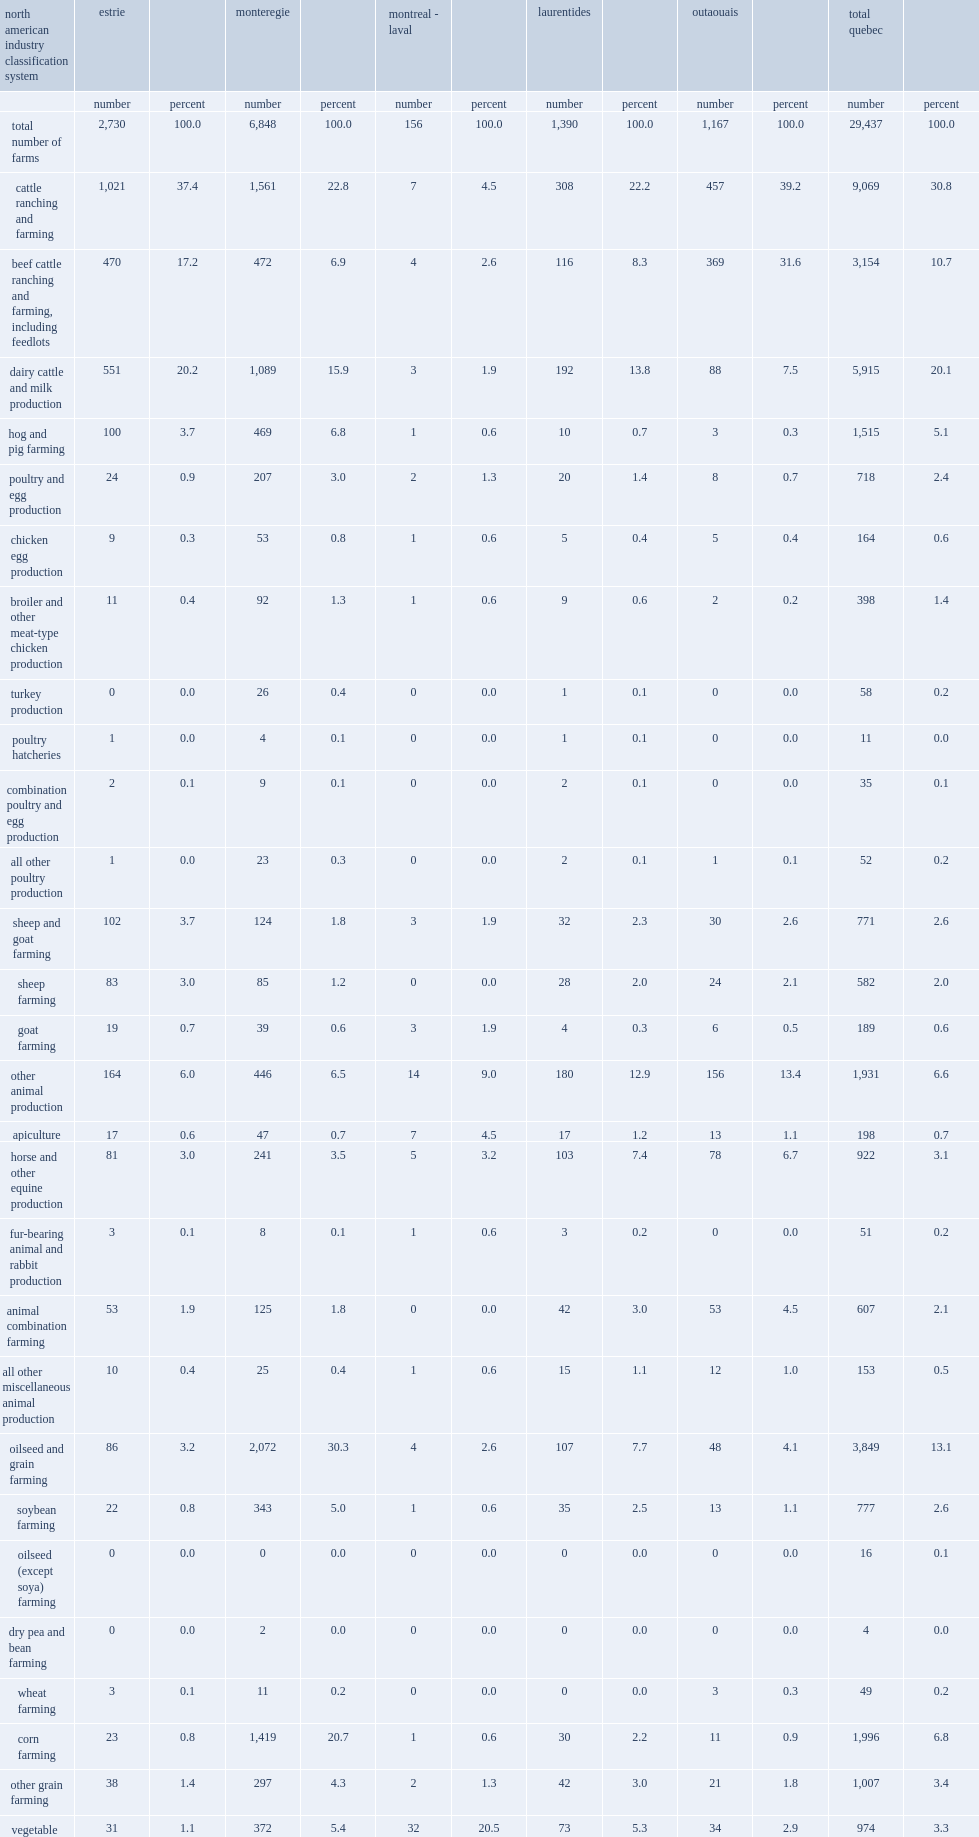For the entire monteregie region, which observation has the highest proportion? Oilseed and grain farming. How many percent of farms in the outaouais region have reported growing hay in 2011? 21.3. 